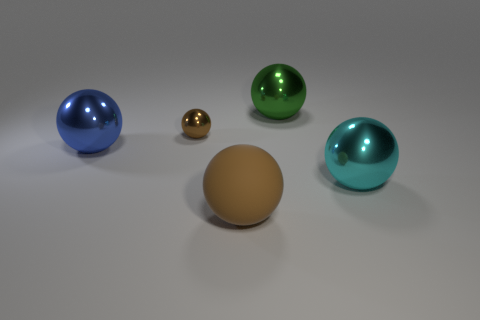Does the large blue metallic object to the left of the green object have the same shape as the small brown shiny object?
Keep it short and to the point. Yes. Are there more green shiny spheres in front of the big blue ball than green metal objects?
Offer a terse response. No. Are there any other things that have the same material as the tiny ball?
Provide a succinct answer. Yes. What is the shape of the matte thing that is the same color as the tiny shiny thing?
Keep it short and to the point. Sphere. What number of cylinders are big green metallic objects or small brown metallic objects?
Make the answer very short. 0. There is a large shiny ball on the left side of the sphere that is in front of the large cyan metallic thing; what color is it?
Your answer should be very brief. Blue. Is the color of the small thing the same as the object right of the big green thing?
Your answer should be very brief. No. There is a brown object that is the same material as the large cyan sphere; what is its size?
Offer a terse response. Small. What size is the shiny ball that is the same color as the matte object?
Your response must be concise. Small. Is the color of the matte sphere the same as the small thing?
Make the answer very short. Yes. 